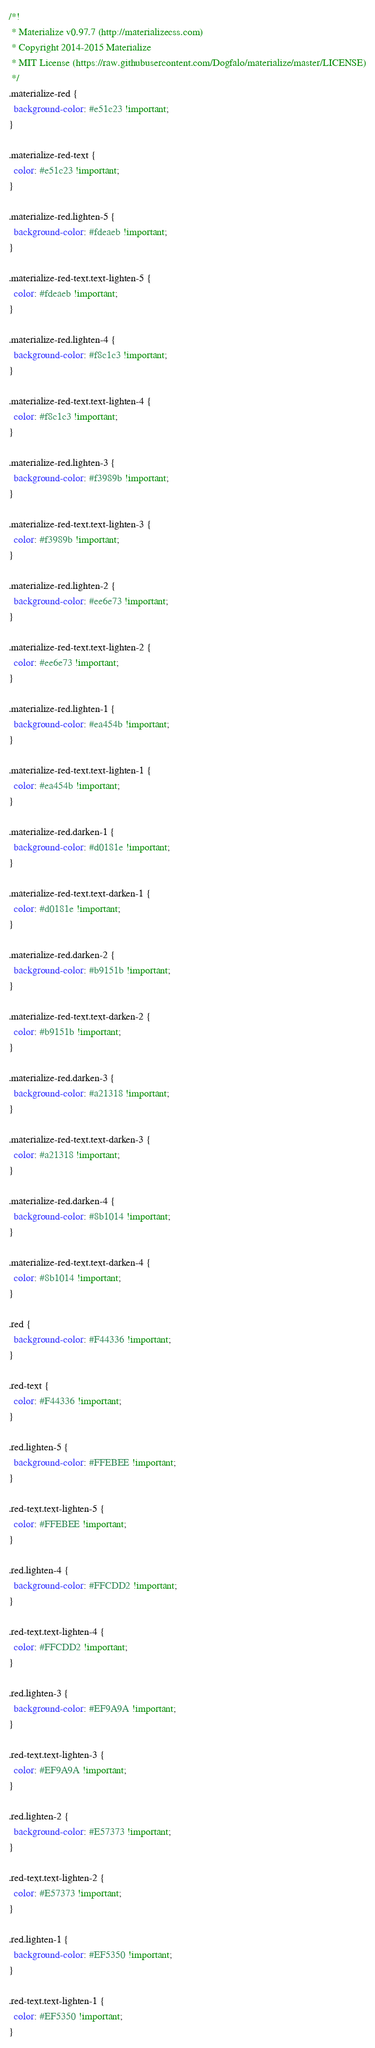<code> <loc_0><loc_0><loc_500><loc_500><_CSS_>/*!
 * Materialize v0.97.7 (http://materializecss.com)
 * Copyright 2014-2015 Materialize
 * MIT License (https://raw.githubusercontent.com/Dogfalo/materialize/master/LICENSE)
 */
.materialize-red {
  background-color: #e51c23 !important;
}

.materialize-red-text {
  color: #e51c23 !important;
}

.materialize-red.lighten-5 {
  background-color: #fdeaeb !important;
}

.materialize-red-text.text-lighten-5 {
  color: #fdeaeb !important;
}

.materialize-red.lighten-4 {
  background-color: #f8c1c3 !important;
}

.materialize-red-text.text-lighten-4 {
  color: #f8c1c3 !important;
}

.materialize-red.lighten-3 {
  background-color: #f3989b !important;
}

.materialize-red-text.text-lighten-3 {
  color: #f3989b !important;
}

.materialize-red.lighten-2 {
  background-color: #ee6e73 !important;
}

.materialize-red-text.text-lighten-2 {
  color: #ee6e73 !important;
}

.materialize-red.lighten-1 {
  background-color: #ea454b !important;
}

.materialize-red-text.text-lighten-1 {
  color: #ea454b !important;
}

.materialize-red.darken-1 {
  background-color: #d0181e !important;
}

.materialize-red-text.text-darken-1 {
  color: #d0181e !important;
}

.materialize-red.darken-2 {
  background-color: #b9151b !important;
}

.materialize-red-text.text-darken-2 {
  color: #b9151b !important;
}

.materialize-red.darken-3 {
  background-color: #a21318 !important;
}

.materialize-red-text.text-darken-3 {
  color: #a21318 !important;
}

.materialize-red.darken-4 {
  background-color: #8b1014 !important;
}

.materialize-red-text.text-darken-4 {
  color: #8b1014 !important;
}

.red {
  background-color: #F44336 !important;
}

.red-text {
  color: #F44336 !important;
}

.red.lighten-5 {
  background-color: #FFEBEE !important;
}

.red-text.text-lighten-5 {
  color: #FFEBEE !important;
}

.red.lighten-4 {
  background-color: #FFCDD2 !important;
}

.red-text.text-lighten-4 {
  color: #FFCDD2 !important;
}

.red.lighten-3 {
  background-color: #EF9A9A !important;
}

.red-text.text-lighten-3 {
  color: #EF9A9A !important;
}

.red.lighten-2 {
  background-color: #E57373 !important;
}

.red-text.text-lighten-2 {
  color: #E57373 !important;
}

.red.lighten-1 {
  background-color: #EF5350 !important;
}

.red-text.text-lighten-1 {
  color: #EF5350 !important;
}
</code> 